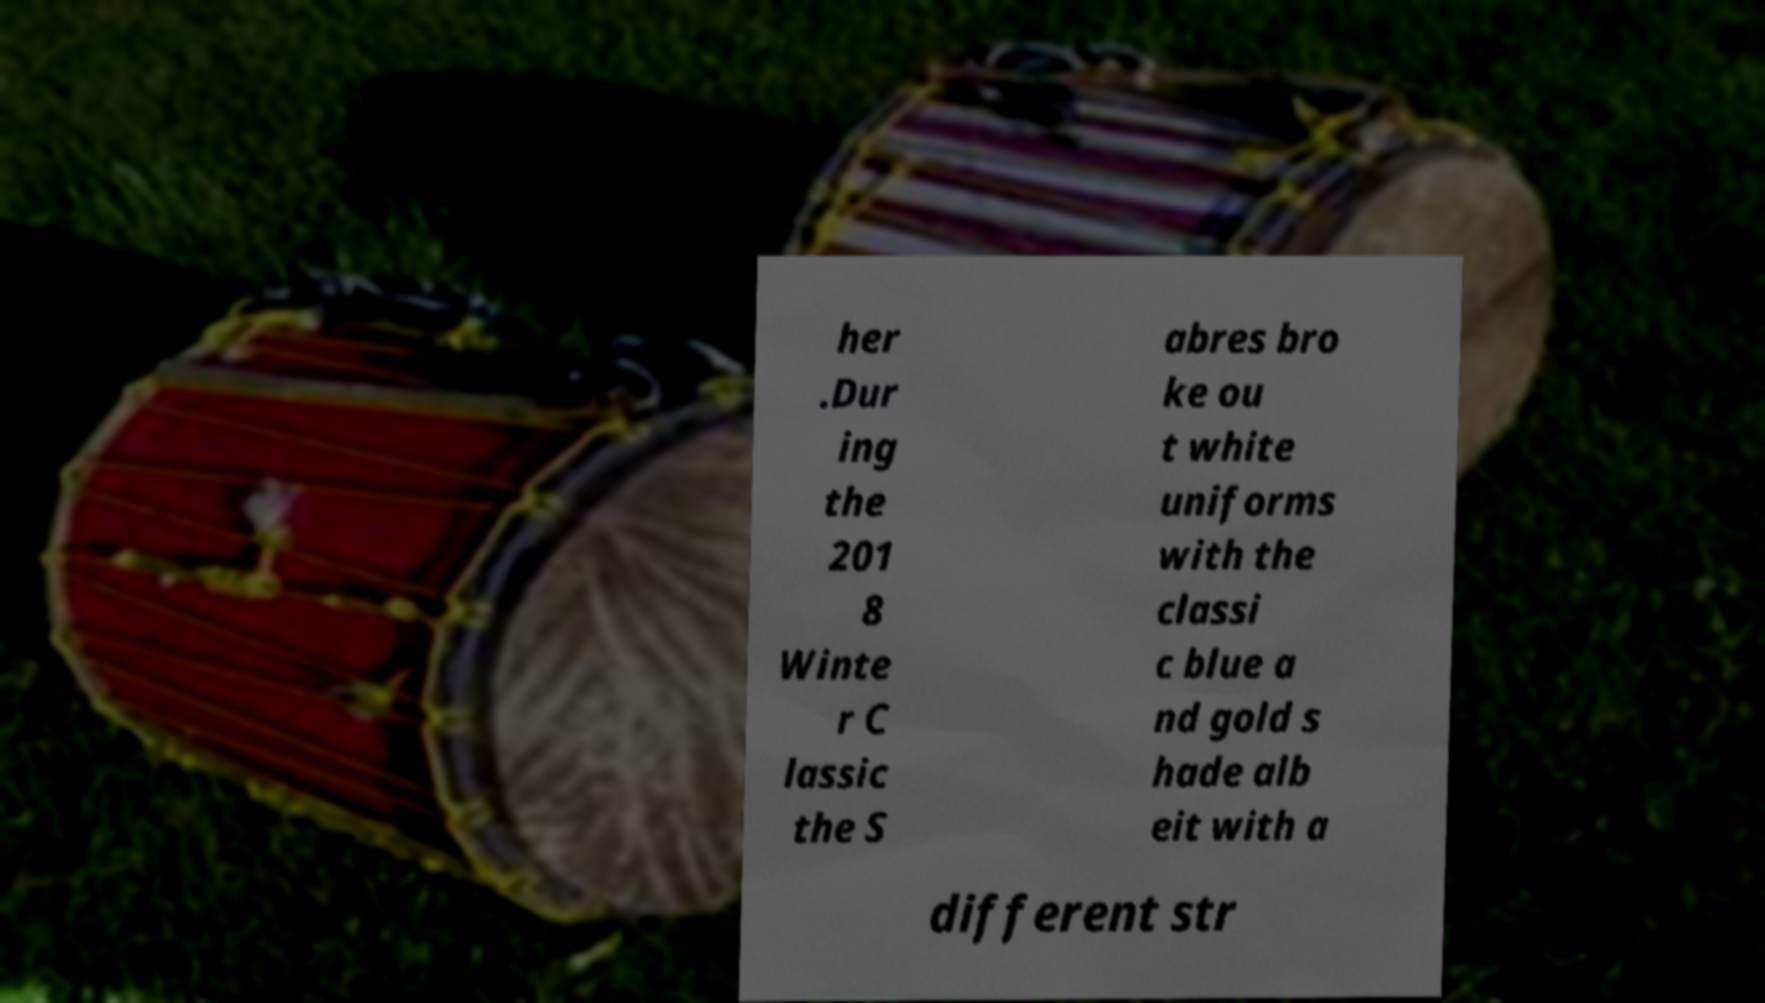Please identify and transcribe the text found in this image. her .Dur ing the 201 8 Winte r C lassic the S abres bro ke ou t white uniforms with the classi c blue a nd gold s hade alb eit with a different str 